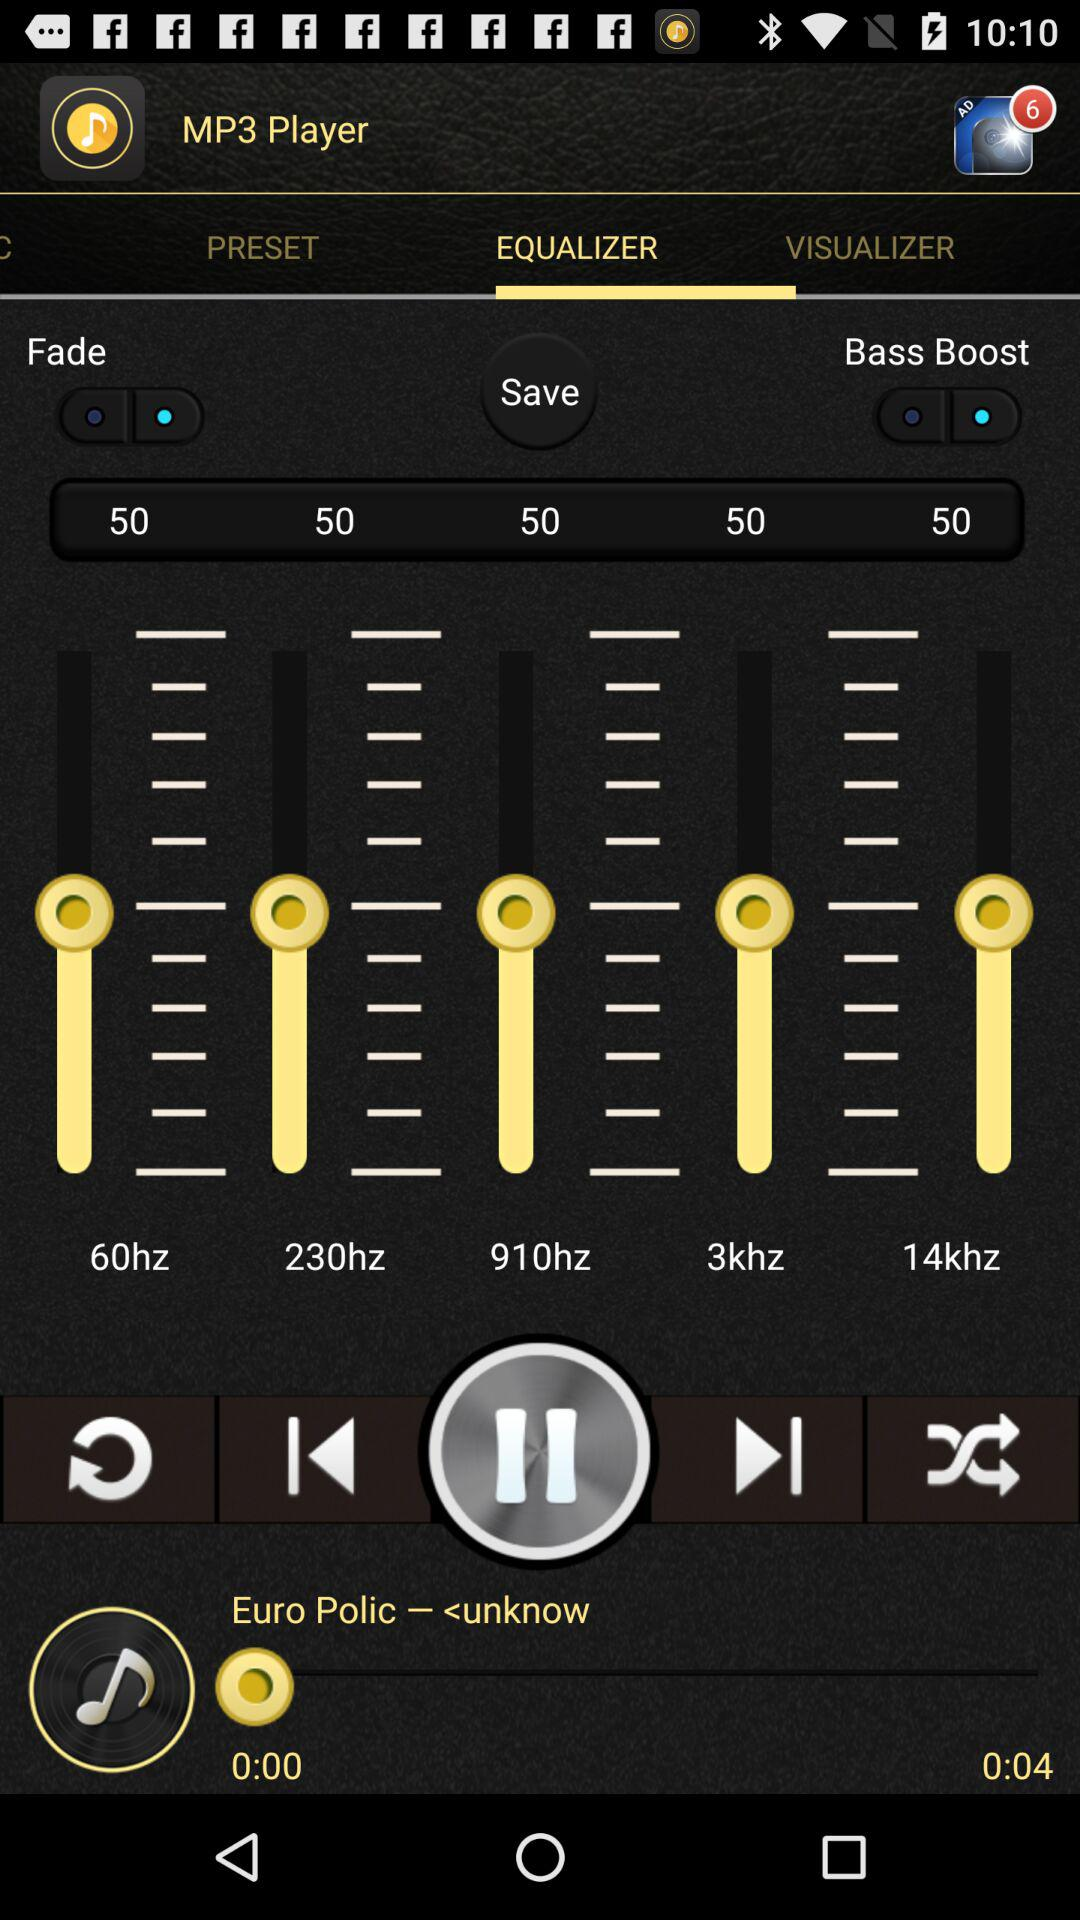How many notifications are there? There are six notifications. 